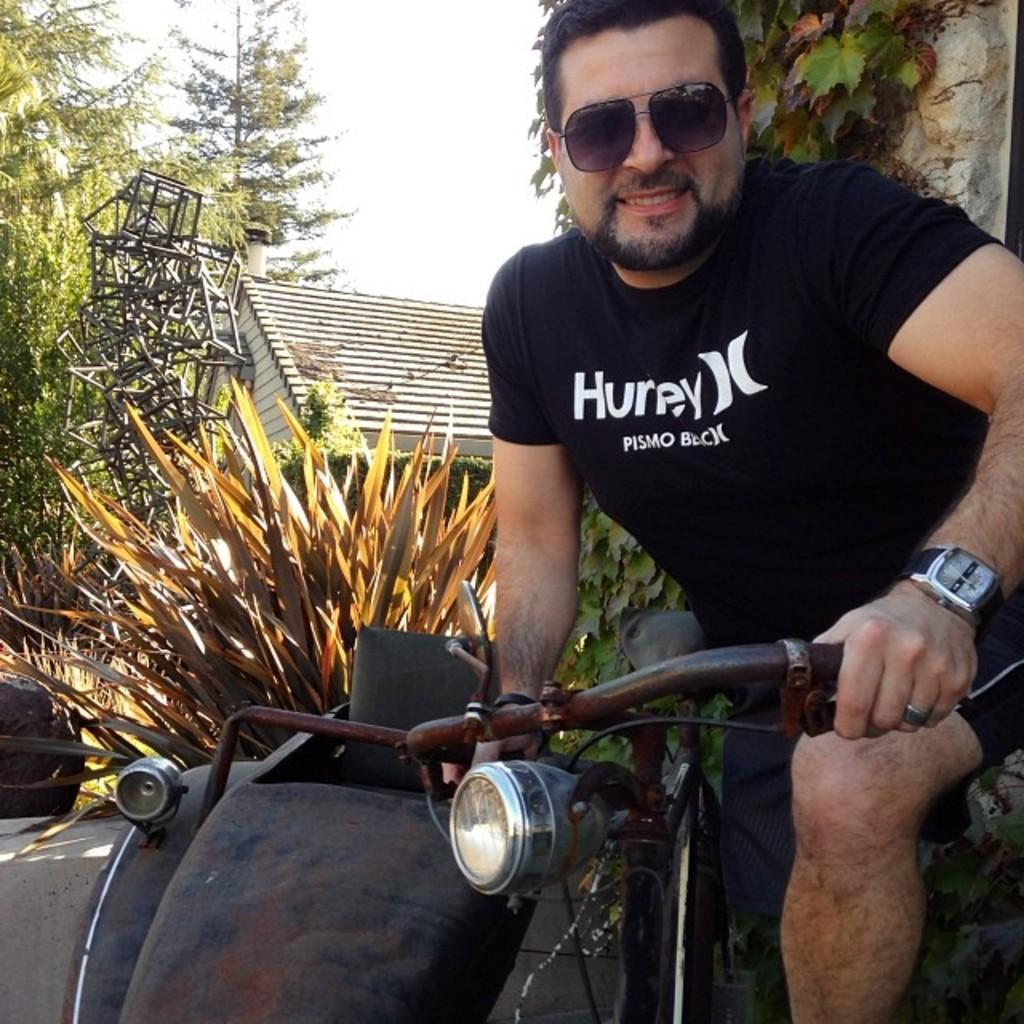Who is present in the image? There is a man in the image. What is the man holding in the image? The man is holding a bicycle. What type of structure can be seen in the image? There is a house in the image. What type of vegetation is present in the image? There are trees and a plant in the image. What month is it in the image? The month cannot be determined from the image, as there is no information about the time of year or date. 